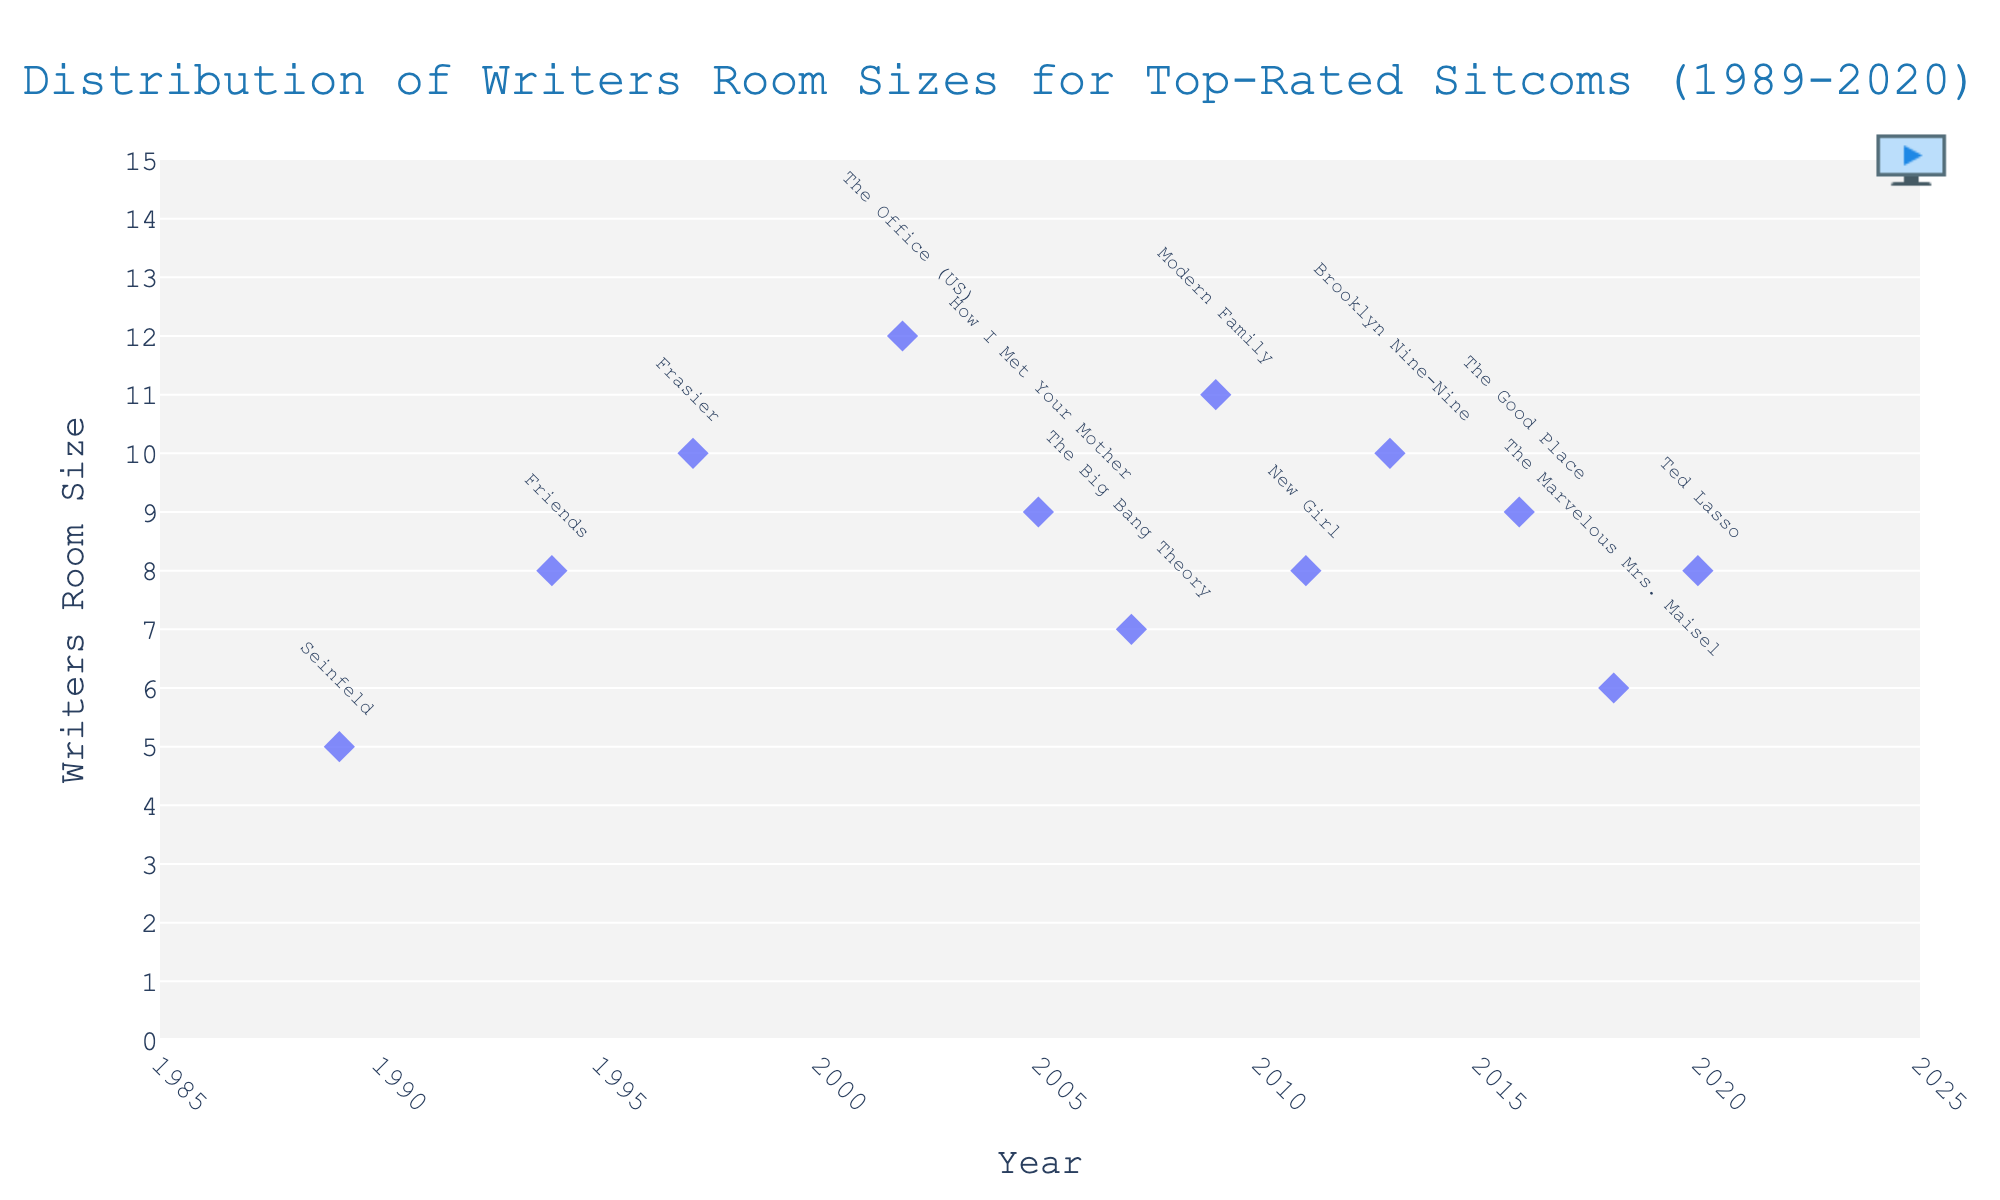What is the title of the figure? The title is displayed at the top center of the plot. It provides context about what the figure represents.
Answer: Distribution of Writers Room Sizes for Top-Rated Sitcoms (1989-2020) What are the years with the highest number of writers in the writers' room? To find this, look at the year on the x-axis where the y-value (Writers Room Size) is at its peak.
Answer: 2002 (The Office, US) and 2009 (Modern Family) How many data points does the figure display? Each sitcom is a data point, represented by a diamond shape on the plot. Count the number of these shapes.
Answer: 12 Which show in 2005 had a writers' room size of 9? Locate the year 2005 on the x-axis, trace up to the point with y-value 9, and refer to the annotation.
Answer: How I Met Your Mother How does the writers' room size for 'Friends' compare to 'Ted Lasso'? Look at the y-values for 'Friends' and 'Ted Lasso', which correspond to their writers' room sizes. Compare the two values.
Answer: Friends has a larger writers' room size (8 vs. 8 for Ted Lasso) What is the range of writers' room sizes shown in the figure? Identify the minimum and maximum y-values displayed on the plot and calculate the difference between them.
Answer: 5 (Seinfeld) to 12 (The Office, US) What is the average writers' room size for the sitcoms from 1989 to 2020? Sum all the y-values of the data points and divide by the total number of data points (12).
Answer: (5+8+10+12+9+7+11+8+10+9+6+8)/12 = 8.5 Which show had the smallest writers' room size and in what year? Locate the point with the smallest y-value on the plot and refer to its annotation.
Answer: Seinfeld, 1989 Between 2018 and 2020, which sitcom had more writers in its room? Compare the y-values (writers' room sizes) of the sitcoms for the years 2018 and 2020.
Answer: Ted Lasso (8) had more than The Marvelous Mrs. Maisel (6) Is there a general trend of increasing or decreasing writers' room size over the years? Observe the overall pattern of data points from left (1989) to right (2020). Identify if they generally go up, down, or stay constant.
Answer: Slightly increasing trend 